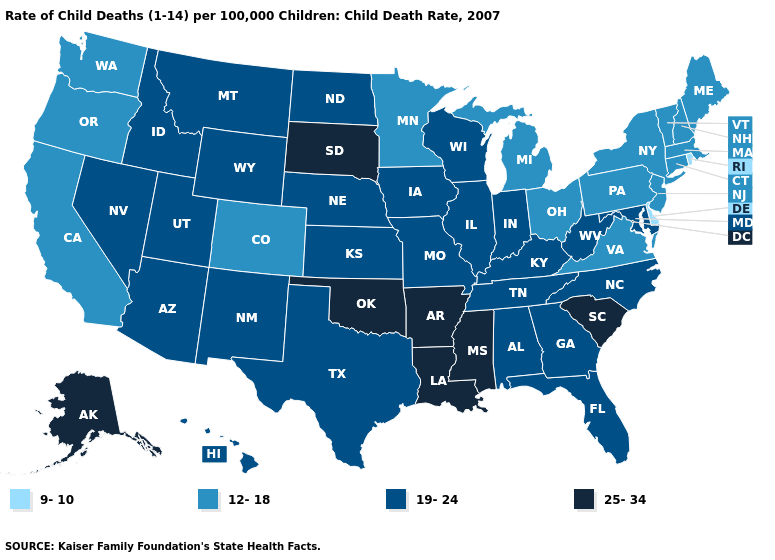Name the states that have a value in the range 9-10?
Concise answer only. Delaware, Rhode Island. What is the value of Rhode Island?
Answer briefly. 9-10. Name the states that have a value in the range 19-24?
Concise answer only. Alabama, Arizona, Florida, Georgia, Hawaii, Idaho, Illinois, Indiana, Iowa, Kansas, Kentucky, Maryland, Missouri, Montana, Nebraska, Nevada, New Mexico, North Carolina, North Dakota, Tennessee, Texas, Utah, West Virginia, Wisconsin, Wyoming. Does Delaware have the lowest value in the South?
Quick response, please. Yes. What is the value of Ohio?
Short answer required. 12-18. What is the lowest value in the West?
Quick response, please. 12-18. Name the states that have a value in the range 25-34?
Concise answer only. Alaska, Arkansas, Louisiana, Mississippi, Oklahoma, South Carolina, South Dakota. What is the highest value in the USA?
Be succinct. 25-34. Which states hav the highest value in the West?
Quick response, please. Alaska. Name the states that have a value in the range 12-18?
Give a very brief answer. California, Colorado, Connecticut, Maine, Massachusetts, Michigan, Minnesota, New Hampshire, New Jersey, New York, Ohio, Oregon, Pennsylvania, Vermont, Virginia, Washington. Does Rhode Island have the lowest value in the Northeast?
Be succinct. Yes. What is the value of Arkansas?
Be succinct. 25-34. What is the lowest value in the USA?
Answer briefly. 9-10. What is the highest value in the USA?
Answer briefly. 25-34. Which states have the highest value in the USA?
Short answer required. Alaska, Arkansas, Louisiana, Mississippi, Oklahoma, South Carolina, South Dakota. 